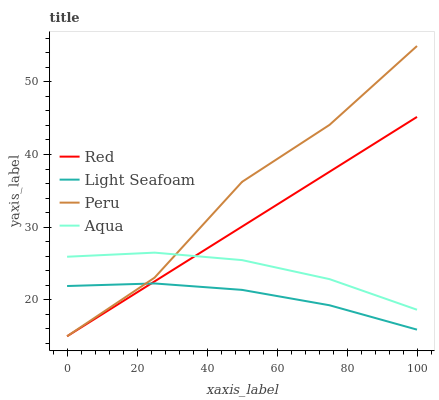Does Light Seafoam have the minimum area under the curve?
Answer yes or no. Yes. Does Peru have the maximum area under the curve?
Answer yes or no. Yes. Does Aqua have the minimum area under the curve?
Answer yes or no. No. Does Aqua have the maximum area under the curve?
Answer yes or no. No. Is Red the smoothest?
Answer yes or no. Yes. Is Peru the roughest?
Answer yes or no. Yes. Is Aqua the smoothest?
Answer yes or no. No. Is Aqua the roughest?
Answer yes or no. No. Does Peru have the lowest value?
Answer yes or no. Yes. Does Aqua have the lowest value?
Answer yes or no. No. Does Peru have the highest value?
Answer yes or no. Yes. Does Aqua have the highest value?
Answer yes or no. No. Is Light Seafoam less than Aqua?
Answer yes or no. Yes. Is Aqua greater than Light Seafoam?
Answer yes or no. Yes. Does Light Seafoam intersect Peru?
Answer yes or no. Yes. Is Light Seafoam less than Peru?
Answer yes or no. No. Is Light Seafoam greater than Peru?
Answer yes or no. No. Does Light Seafoam intersect Aqua?
Answer yes or no. No. 